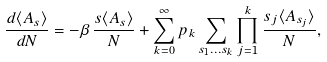Convert formula to latex. <formula><loc_0><loc_0><loc_500><loc_500>\frac { d \langle A _ { s } \rangle } { d N } = - \beta \, \frac { s \langle A _ { s } \rangle } { N } + \sum _ { k = 0 } ^ { \infty } p _ { k } \sum _ { s _ { 1 } \dots s _ { k } } \prod _ { j = 1 } ^ { k } \frac { s _ { j } \langle A _ { s _ { j } } \rangle } { N } ,</formula> 